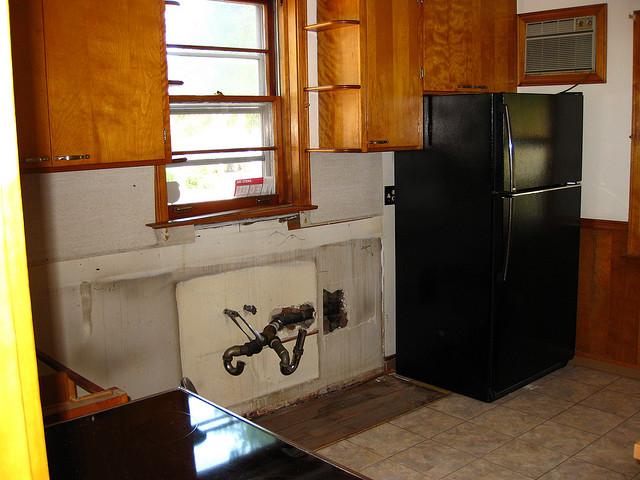What color are the cabinets?
Quick response, please. Brown. How many appliances are there?
Keep it brief. 1. Can you currently wash dishes in this kitchen?
Be succinct. No. 